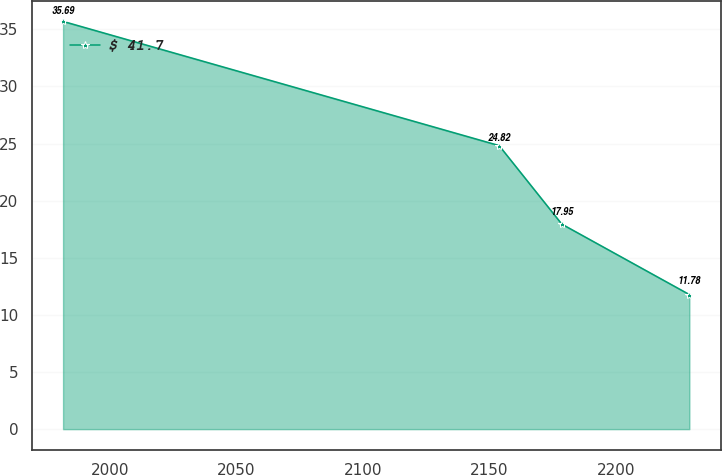Convert chart. <chart><loc_0><loc_0><loc_500><loc_500><line_chart><ecel><fcel>$ 41.7<nl><fcel>1981.36<fcel>35.69<nl><fcel>2153.85<fcel>24.82<nl><fcel>2178.63<fcel>17.95<nl><fcel>2229.12<fcel>11.78<nl></chart> 